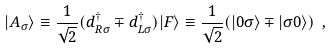<formula> <loc_0><loc_0><loc_500><loc_500>| A _ { \sigma } \rangle \equiv \frac { 1 } { \sqrt { 2 } } ( d ^ { \dag } _ { R \sigma } \mp d ^ { \dag } _ { L \sigma } ) | F \rangle \equiv \frac { 1 } { \sqrt { 2 } } ( | 0 \sigma \rangle \mp | \sigma 0 \rangle ) \ ,</formula> 